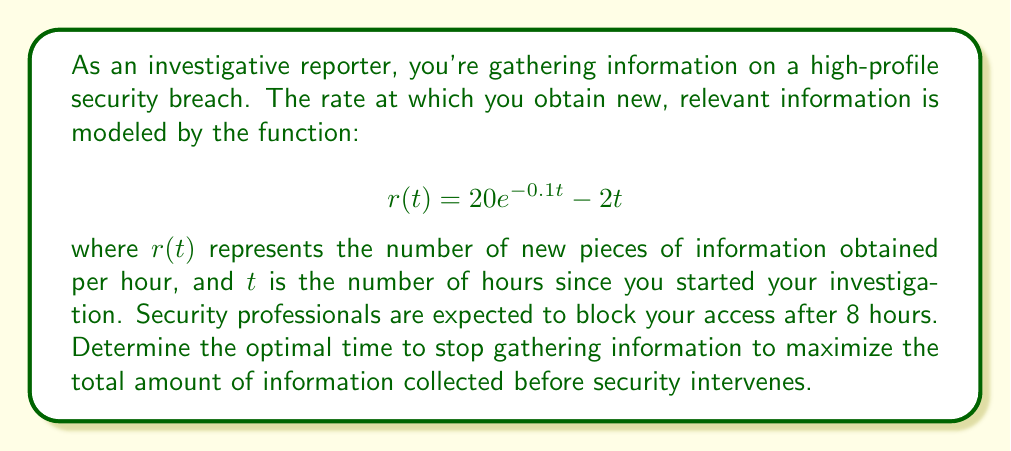Can you answer this question? To solve this problem, we need to follow these steps:

1) First, we need to find the total amount of information gathered over time. This is represented by the integral of the rate function:

   $$I(t) = \int_0^t r(u) du = \int_0^t (20e^{-0.1u} - 2u) du$$

2) Solve this integral:
   
   $$I(t) = [-200e^{-0.1u}]_0^t - [u^2]_0^t$$
   $$I(t) = -200e^{-0.1t} + 200 - t^2$$

3) To find the optimal time, we need to find the maximum of this function. The maximum occurs where the derivative is zero:

   $$I'(t) = 20e^{-0.1t} - 2t$$

4) Set this equal to zero and solve:

   $$20e^{-0.1t} - 2t = 0$$
   $$20e^{-0.1t} = 2t$$

5) This equation can't be solved algebraically. We need to use numerical methods or graphing to find the solution. Using a graphing calculator or computer software, we find that this equation is satisfied when:

   $$t \approx 3.58$$

6) We should verify that this is indeed a maximum by checking the second derivative:

   $$I''(t) = -2e^{-0.1t} - 2$$

   At $t = 3.58$, this is negative, confirming a maximum.

7) Finally, we need to compare this optimal time with the 8-hour limit imposed by security. Since 3.58 < 8, the optimal time is not affected by the security limit.
Answer: The optimal time to stop gathering information is approximately 3.58 hours after starting the investigation. 